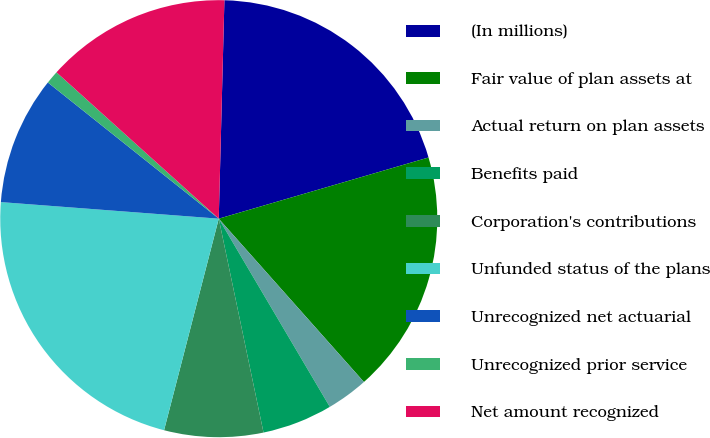Convert chart to OTSL. <chart><loc_0><loc_0><loc_500><loc_500><pie_chart><fcel>(In millions)<fcel>Fair value of plan assets at<fcel>Actual return on plan assets<fcel>Benefits paid<fcel>Corporation's contributions<fcel>Unfunded status of the plans<fcel>Unrecognized net actuarial<fcel>Unrecognized prior service<fcel>Net amount recognized<nl><fcel>20.07%<fcel>17.95%<fcel>3.08%<fcel>5.2%<fcel>7.31%<fcel>22.18%<fcel>9.5%<fcel>0.97%<fcel>13.73%<nl></chart> 